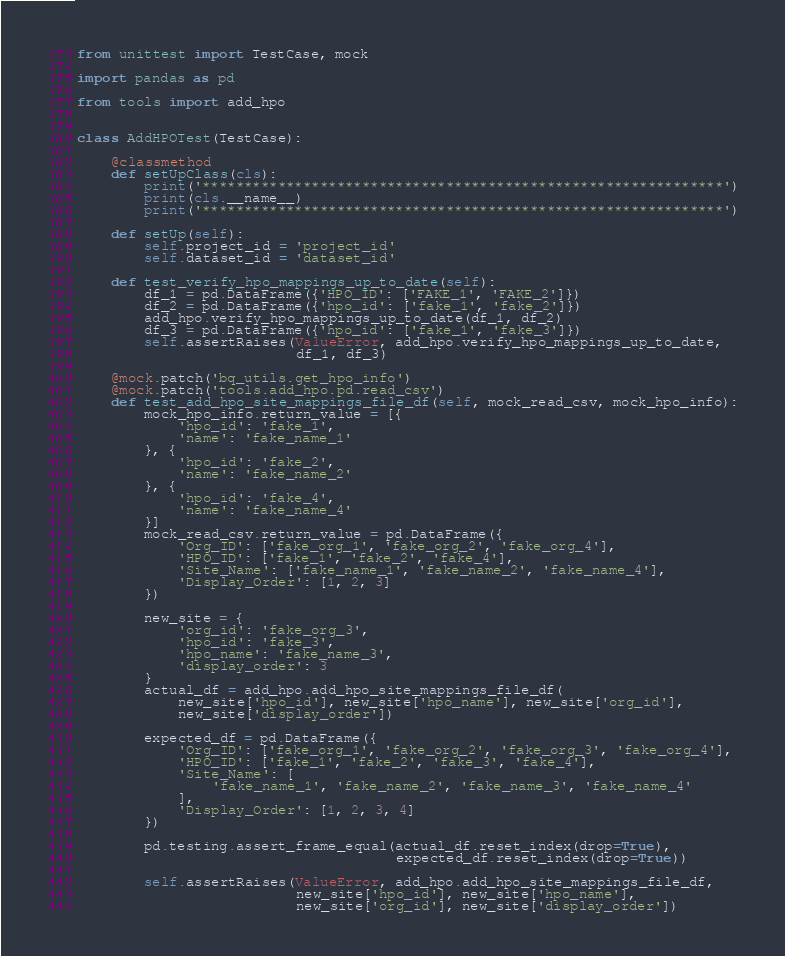Convert code to text. <code><loc_0><loc_0><loc_500><loc_500><_Python_>from unittest import TestCase, mock

import pandas as pd

from tools import add_hpo


class AddHPOTest(TestCase):

    @classmethod
    def setUpClass(cls):
        print('**************************************************************')
        print(cls.__name__)
        print('**************************************************************')

    def setUp(self):
        self.project_id = 'project_id'
        self.dataset_id = 'dataset_id'

    def test_verify_hpo_mappings_up_to_date(self):
        df_1 = pd.DataFrame({'HPO_ID': ['FAKE_1', 'FAKE_2']})
        df_2 = pd.DataFrame({'hpo_id': ['fake_1', 'fake_2']})
        add_hpo.verify_hpo_mappings_up_to_date(df_1, df_2)
        df_3 = pd.DataFrame({'hpo_id': ['fake_1', 'fake_3']})
        self.assertRaises(ValueError, add_hpo.verify_hpo_mappings_up_to_date,
                          df_1, df_3)

    @mock.patch('bq_utils.get_hpo_info')
    @mock.patch('tools.add_hpo.pd.read_csv')
    def test_add_hpo_site_mappings_file_df(self, mock_read_csv, mock_hpo_info):
        mock_hpo_info.return_value = [{
            'hpo_id': 'fake_1',
            'name': 'fake_name_1'
        }, {
            'hpo_id': 'fake_2',
            'name': 'fake_name_2'
        }, {
            'hpo_id': 'fake_4',
            'name': 'fake_name_4'
        }]
        mock_read_csv.return_value = pd.DataFrame({
            'Org_ID': ['fake_org_1', 'fake_org_2', 'fake_org_4'],
            'HPO_ID': ['fake_1', 'fake_2', 'fake_4'],
            'Site_Name': ['fake_name_1', 'fake_name_2', 'fake_name_4'],
            'Display_Order': [1, 2, 3]
        })

        new_site = {
            'org_id': 'fake_org_3',
            'hpo_id': 'fake_3',
            'hpo_name': 'fake_name_3',
            'display_order': 3
        }
        actual_df = add_hpo.add_hpo_site_mappings_file_df(
            new_site['hpo_id'], new_site['hpo_name'], new_site['org_id'],
            new_site['display_order'])

        expected_df = pd.DataFrame({
            'Org_ID': ['fake_org_1', 'fake_org_2', 'fake_org_3', 'fake_org_4'],
            'HPO_ID': ['fake_1', 'fake_2', 'fake_3', 'fake_4'],
            'Site_Name': [
                'fake_name_1', 'fake_name_2', 'fake_name_3', 'fake_name_4'
            ],
            'Display_Order': [1, 2, 3, 4]
        })

        pd.testing.assert_frame_equal(actual_df.reset_index(drop=True),
                                      expected_df.reset_index(drop=True))

        self.assertRaises(ValueError, add_hpo.add_hpo_site_mappings_file_df,
                          new_site['hpo_id'], new_site['hpo_name'],
                          new_site['org_id'], new_site['display_order'])
</code> 